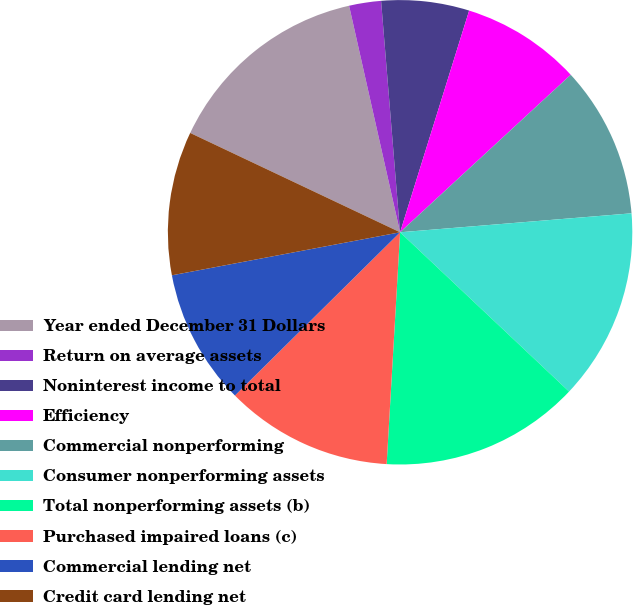Convert chart. <chart><loc_0><loc_0><loc_500><loc_500><pie_chart><fcel>Year ended December 31 Dollars<fcel>Return on average assets<fcel>Noninterest income to total<fcel>Efficiency<fcel>Commercial nonperforming<fcel>Consumer nonperforming assets<fcel>Total nonperforming assets (b)<fcel>Purchased impaired loans (c)<fcel>Commercial lending net<fcel>Credit card lending net<nl><fcel>14.44%<fcel>2.22%<fcel>6.11%<fcel>8.33%<fcel>10.56%<fcel>13.33%<fcel>13.89%<fcel>11.67%<fcel>9.44%<fcel>10.0%<nl></chart> 